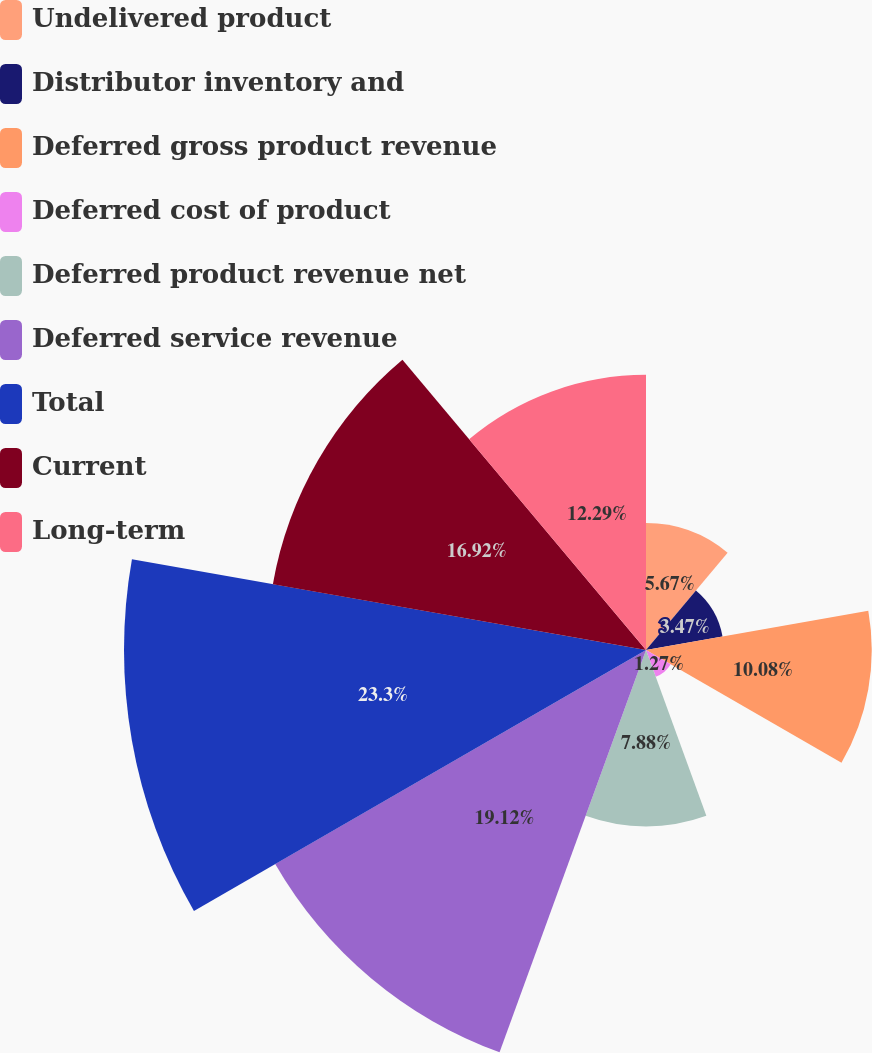Convert chart to OTSL. <chart><loc_0><loc_0><loc_500><loc_500><pie_chart><fcel>Undelivered product<fcel>Distributor inventory and<fcel>Deferred gross product revenue<fcel>Deferred cost of product<fcel>Deferred product revenue net<fcel>Deferred service revenue<fcel>Total<fcel>Current<fcel>Long-term<nl><fcel>5.67%<fcel>3.47%<fcel>10.08%<fcel>1.27%<fcel>7.88%<fcel>19.12%<fcel>23.31%<fcel>16.92%<fcel>12.29%<nl></chart> 